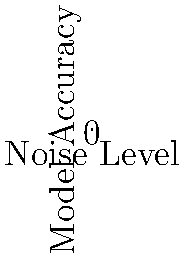Analyze the impact of noise addition on the accuracy of a machine learning model used for privacy-preserving computations. Based on the plots, at what noise level does the accuracy of the model with added noise drop below 70%? To solve this problem, we need to follow these steps:

1. Understand the graph:
   - The blue line represents the model accuracy without noise.
   - The red line represents the model accuracy with added noise.
   - The x-axis shows the noise level, and the y-axis shows the model accuracy.

2. Locate the 70% accuracy line:
   - We need to find where the red line (with noise) crosses the 0.70 mark on the y-axis.

3. Trace the point to the x-axis:
   - From the intersection point, draw an imaginary vertical line down to the x-axis.

4. Read the noise level:
   - The point where this imaginary line meets the x-axis is our answer.

5. Interpret the result:
   - By observing the graph, we can see that the red line crosses the 0.70 accuracy mark between noise levels 6 and 7.
   - More precisely, it appears to be closer to 6 than 7.

Therefore, the noise level at which the accuracy drops below 70% is approximately 6.
Answer: 6 